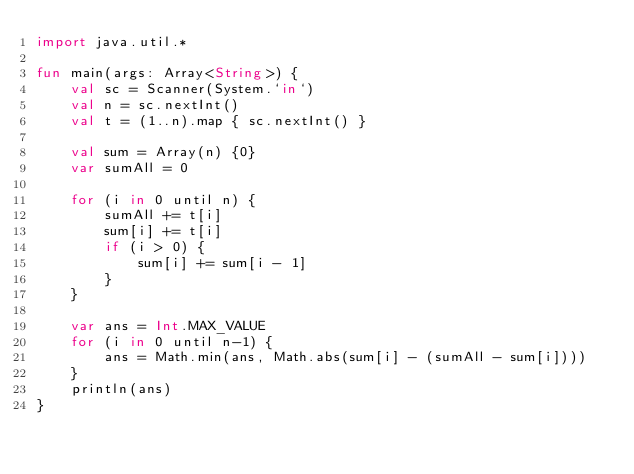<code> <loc_0><loc_0><loc_500><loc_500><_Kotlin_>import java.util.*

fun main(args: Array<String>) {
    val sc = Scanner(System.`in`)
    val n = sc.nextInt()
    val t = (1..n).map { sc.nextInt() }

    val sum = Array(n) {0}
    var sumAll = 0

    for (i in 0 until n) {
        sumAll += t[i]
        sum[i] += t[i]
        if (i > 0) {
            sum[i] += sum[i - 1]
        }
    }

    var ans = Int.MAX_VALUE
    for (i in 0 until n-1) {
        ans = Math.min(ans, Math.abs(sum[i] - (sumAll - sum[i])))
    }
    println(ans)
}</code> 